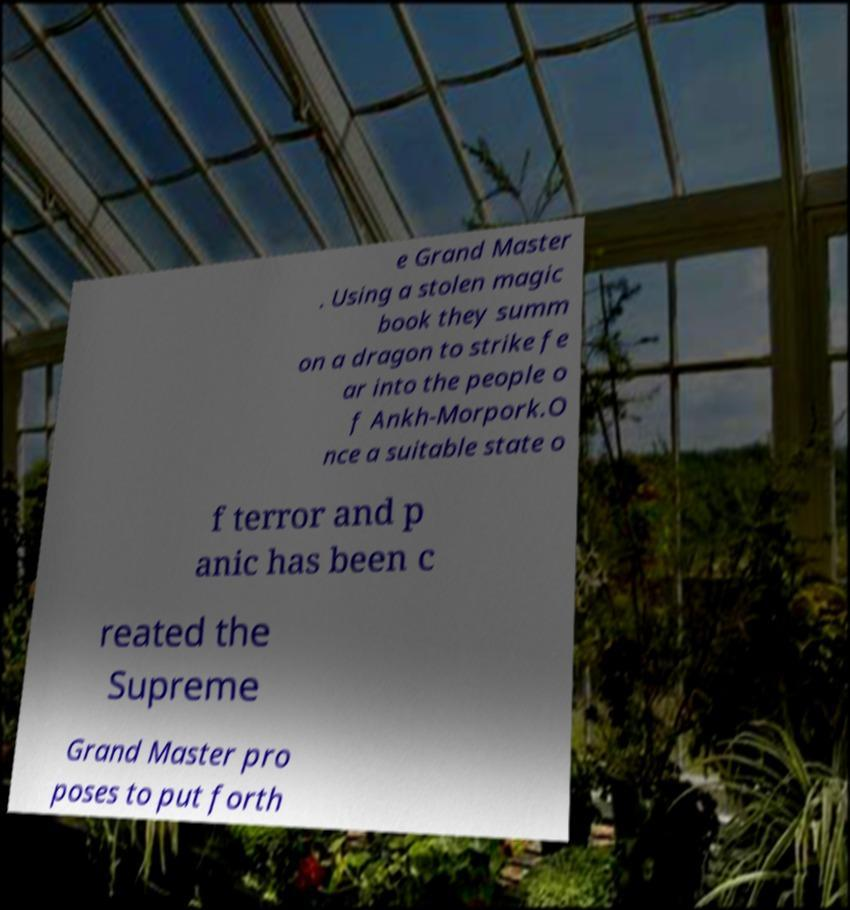For documentation purposes, I need the text within this image transcribed. Could you provide that? e Grand Master . Using a stolen magic book they summ on a dragon to strike fe ar into the people o f Ankh-Morpork.O nce a suitable state o f terror and p anic has been c reated the Supreme Grand Master pro poses to put forth 